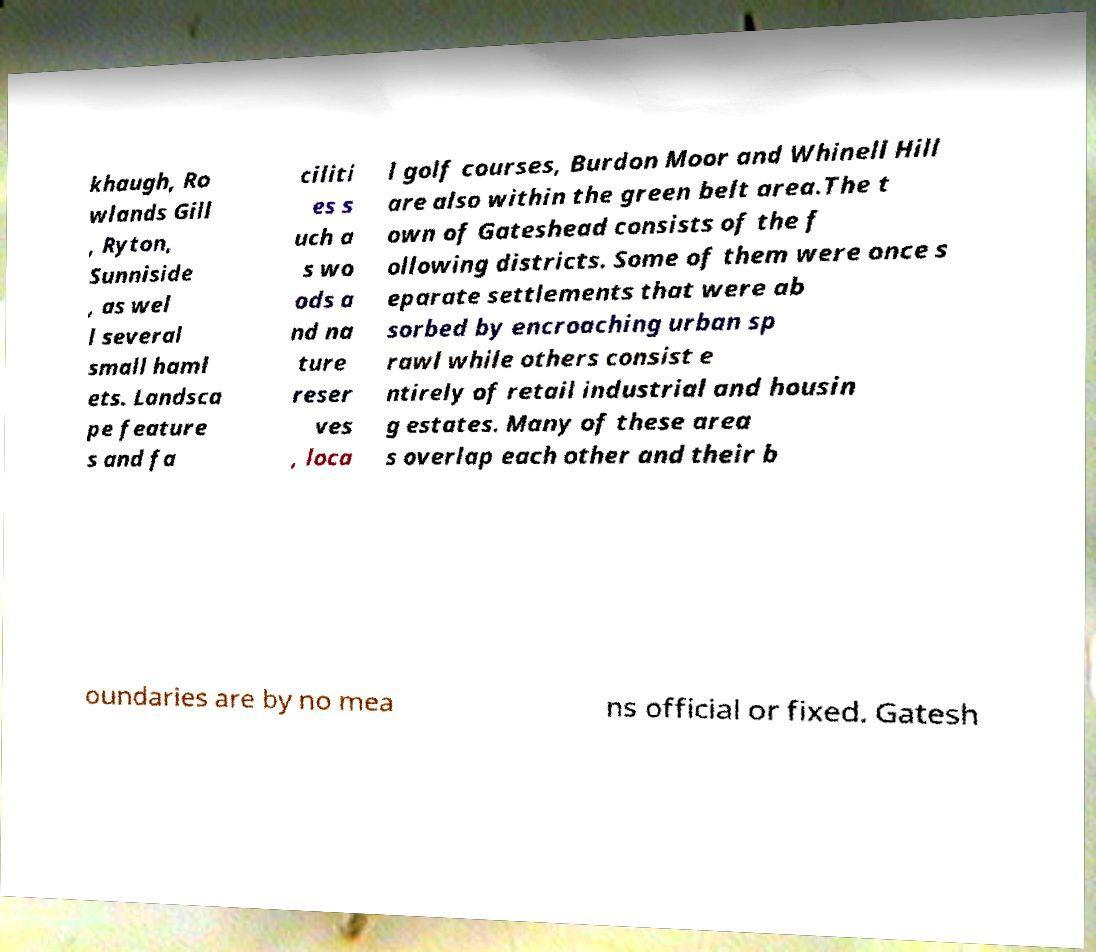I need the written content from this picture converted into text. Can you do that? khaugh, Ro wlands Gill , Ryton, Sunniside , as wel l several small haml ets. Landsca pe feature s and fa ciliti es s uch a s wo ods a nd na ture reser ves , loca l golf courses, Burdon Moor and Whinell Hill are also within the green belt area.The t own of Gateshead consists of the f ollowing districts. Some of them were once s eparate settlements that were ab sorbed by encroaching urban sp rawl while others consist e ntirely of retail industrial and housin g estates. Many of these area s overlap each other and their b oundaries are by no mea ns official or fixed. Gatesh 